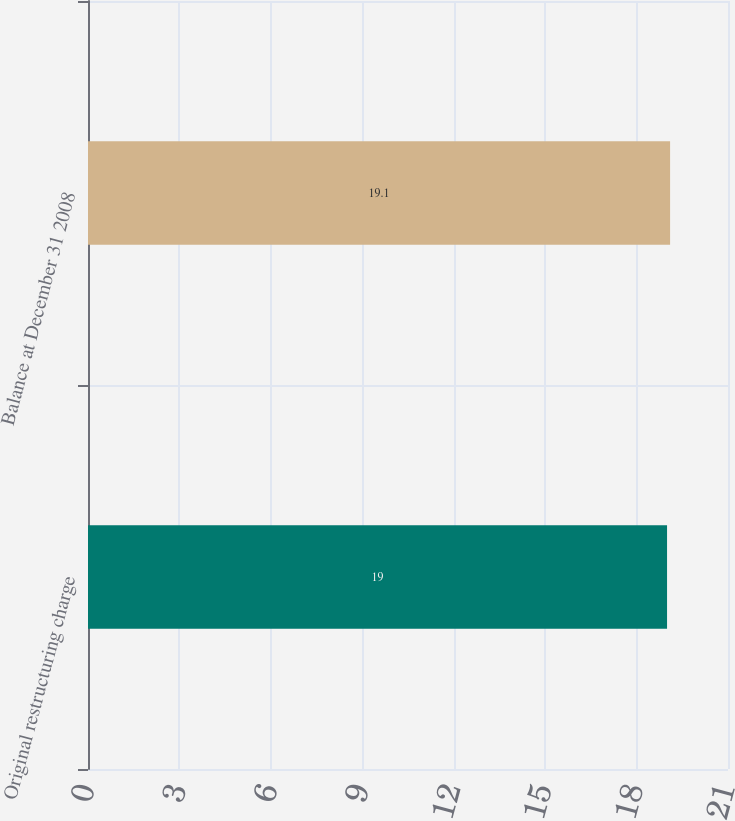Convert chart to OTSL. <chart><loc_0><loc_0><loc_500><loc_500><bar_chart><fcel>Original restructuring charge<fcel>Balance at December 31 2008<nl><fcel>19<fcel>19.1<nl></chart> 